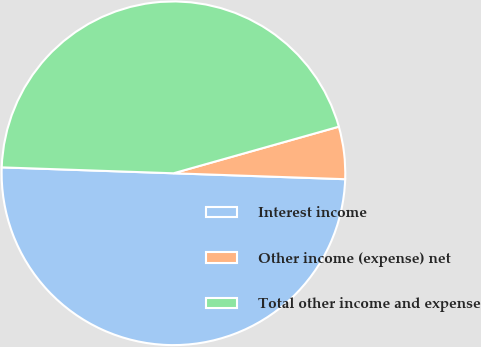Convert chart to OTSL. <chart><loc_0><loc_0><loc_500><loc_500><pie_chart><fcel>Interest income<fcel>Other income (expense) net<fcel>Total other income and expense<nl><fcel>50.0%<fcel>4.92%<fcel>45.08%<nl></chart> 